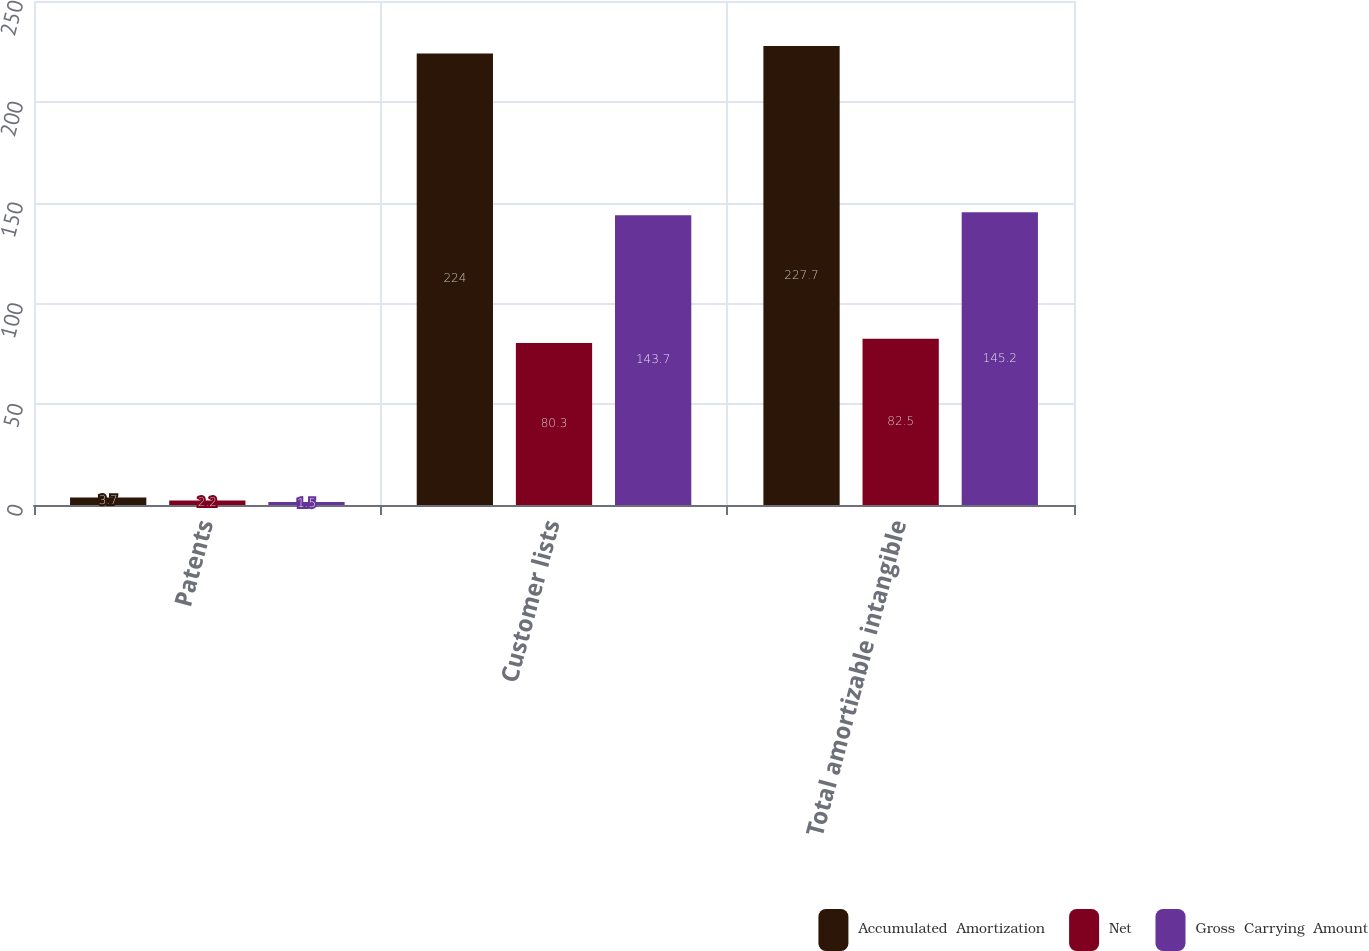Convert chart. <chart><loc_0><loc_0><loc_500><loc_500><stacked_bar_chart><ecel><fcel>Patents<fcel>Customer lists<fcel>Total amortizable intangible<nl><fcel>Accumulated  Amortization<fcel>3.7<fcel>224<fcel>227.7<nl><fcel>Net<fcel>2.2<fcel>80.3<fcel>82.5<nl><fcel>Gross  Carrying  Amount<fcel>1.5<fcel>143.7<fcel>145.2<nl></chart> 